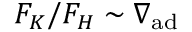<formula> <loc_0><loc_0><loc_500><loc_500>F _ { K } / F _ { H } \sim \nabla _ { a d }</formula> 